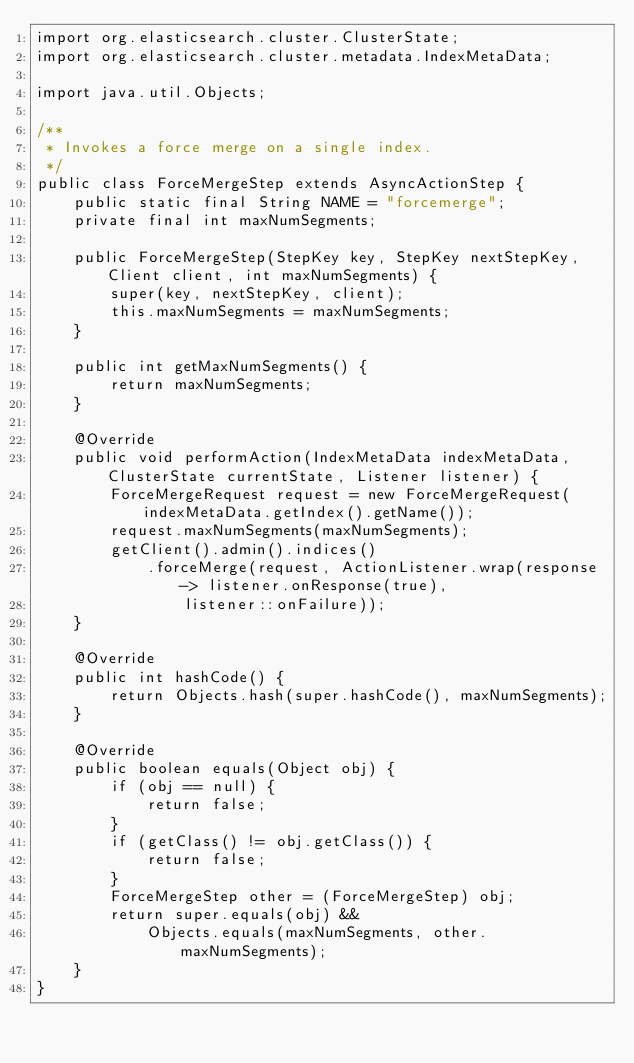Convert code to text. <code><loc_0><loc_0><loc_500><loc_500><_Java_>import org.elasticsearch.cluster.ClusterState;
import org.elasticsearch.cluster.metadata.IndexMetaData;

import java.util.Objects;

/**
 * Invokes a force merge on a single index.
 */
public class ForceMergeStep extends AsyncActionStep {
    public static final String NAME = "forcemerge";
    private final int maxNumSegments;

    public ForceMergeStep(StepKey key, StepKey nextStepKey, Client client, int maxNumSegments) {
        super(key, nextStepKey, client);
        this.maxNumSegments = maxNumSegments;
    }

    public int getMaxNumSegments() {
        return maxNumSegments;
    }

    @Override
    public void performAction(IndexMetaData indexMetaData, ClusterState currentState, Listener listener) {
        ForceMergeRequest request = new ForceMergeRequest(indexMetaData.getIndex().getName());
        request.maxNumSegments(maxNumSegments);
        getClient().admin().indices()
            .forceMerge(request, ActionListener.wrap(response -> listener.onResponse(true),
                listener::onFailure));
    }

    @Override
    public int hashCode() {
        return Objects.hash(super.hashCode(), maxNumSegments);
    }

    @Override
    public boolean equals(Object obj) {
        if (obj == null) {
            return false;
        }
        if (getClass() != obj.getClass()) {
            return false;
        }
        ForceMergeStep other = (ForceMergeStep) obj;
        return super.equals(obj) &&
            Objects.equals(maxNumSegments, other.maxNumSegments);
    }
}
</code> 